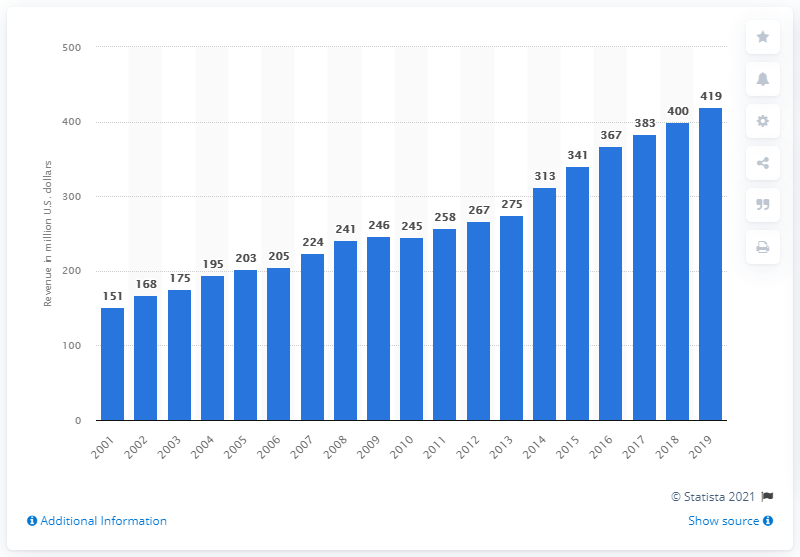Identify some key points in this picture. The revenue of the Tampa Bay Buccaneers in 2019 was $419 million. 